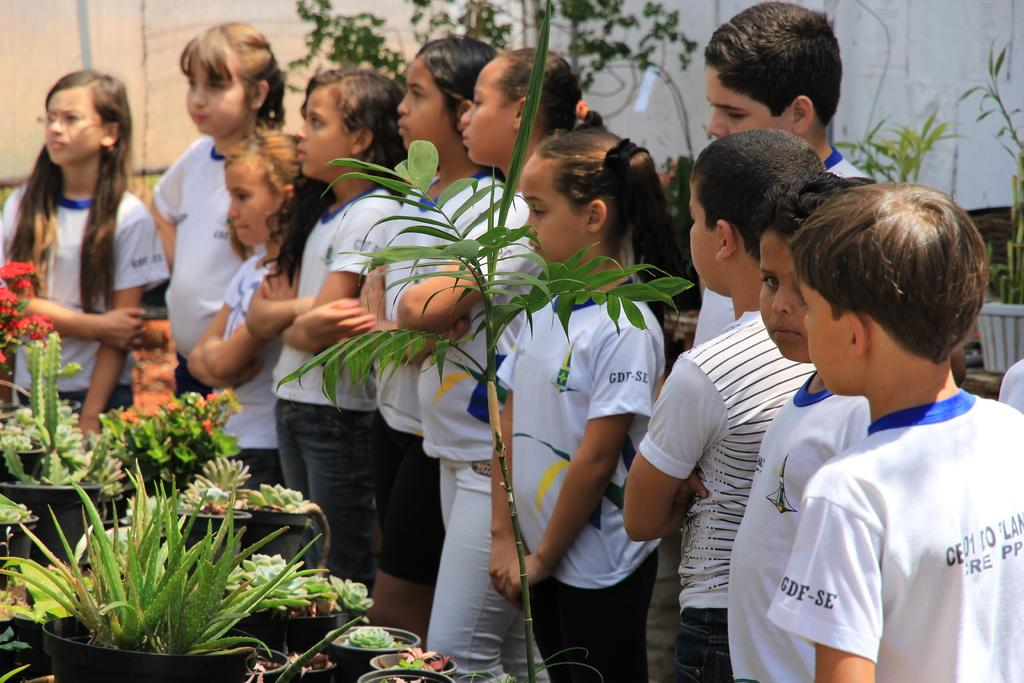How many children are in the image? There are many children in the image. What are the children wearing? The children are wearing white T-shirts. What can be seen on the left side of the image? There are potted plants on the left side of the image. What is visible in the background of the image? There is a wall and plants in the background of the image. What story is being told by the children in the image? There is no story being told by the children in the image. 